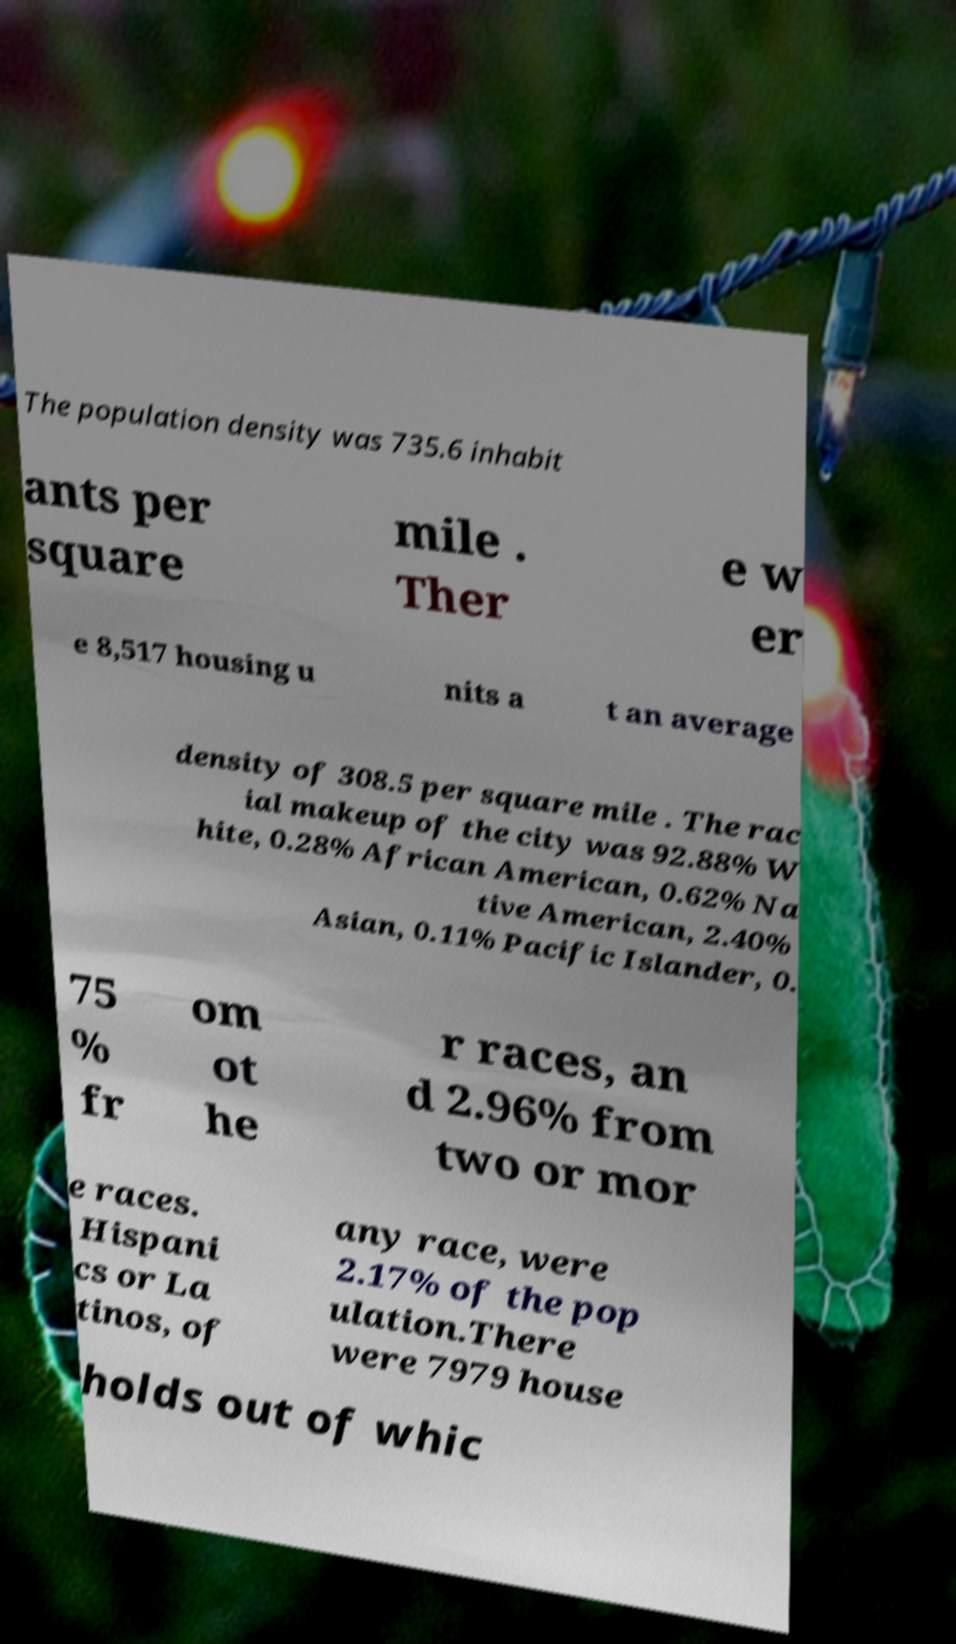Could you assist in decoding the text presented in this image and type it out clearly? The population density was 735.6 inhabit ants per square mile . Ther e w er e 8,517 housing u nits a t an average density of 308.5 per square mile . The rac ial makeup of the city was 92.88% W hite, 0.28% African American, 0.62% Na tive American, 2.40% Asian, 0.11% Pacific Islander, 0. 75 % fr om ot he r races, an d 2.96% from two or mor e races. Hispani cs or La tinos, of any race, were 2.17% of the pop ulation.There were 7979 house holds out of whic 